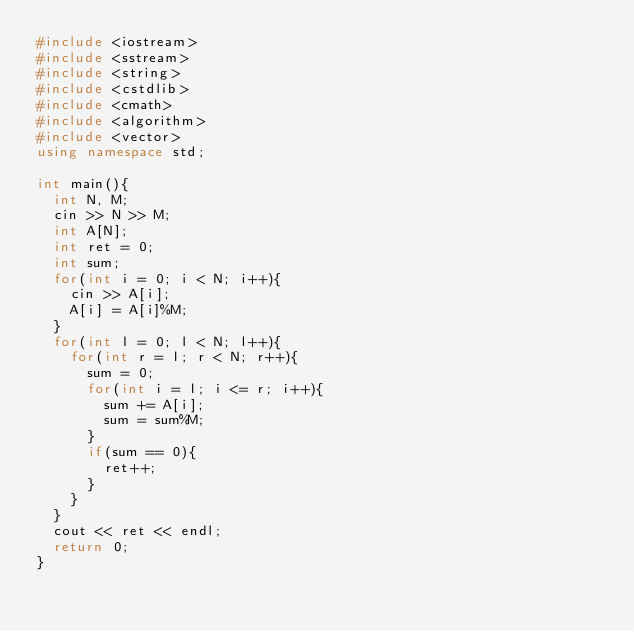Convert code to text. <code><loc_0><loc_0><loc_500><loc_500><_C++_>#include <iostream>
#include <sstream>
#include <string>
#include <cstdlib>
#include <cmath>
#include <algorithm>
#include <vector>
using namespace std;

int main(){
	int N, M;
	cin >> N >> M;
	int A[N];
	int ret = 0;
	int sum;
	for(int i = 0; i < N; i++){
		cin >> A[i];
		A[i] = A[i]%M;
	}
	for(int l = 0; l < N; l++){
		for(int r = l; r < N; r++){
			sum = 0;
			for(int i = l; i <= r; i++){
				sum += A[i];
				sum = sum%M;
			}
			if(sum == 0){
				ret++;
			}
		}
	}
	cout << ret << endl;
	return 0;
}</code> 